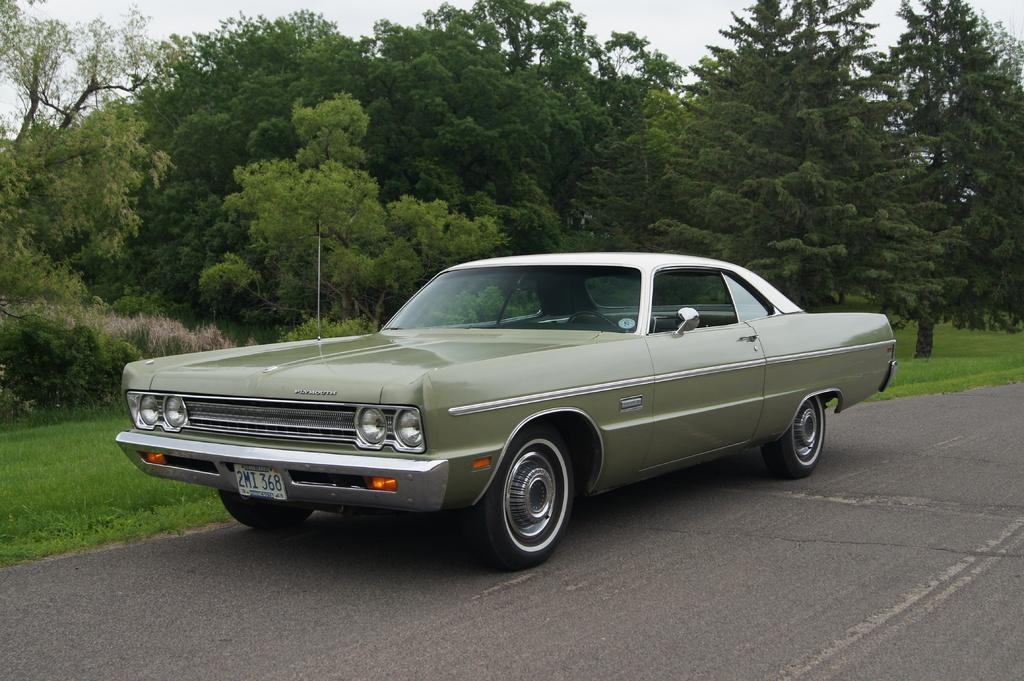What type of car is in the image? There is a green vintage car in the image. Where is the car located? The car is on the road. What can be seen in the background of the image? There are trees visible in the image, and they are on a grassland. What is visible above the trees in the image? The sky is visible in the image. How many teeth can be seen in the image? There are no teeth visible in the image. 